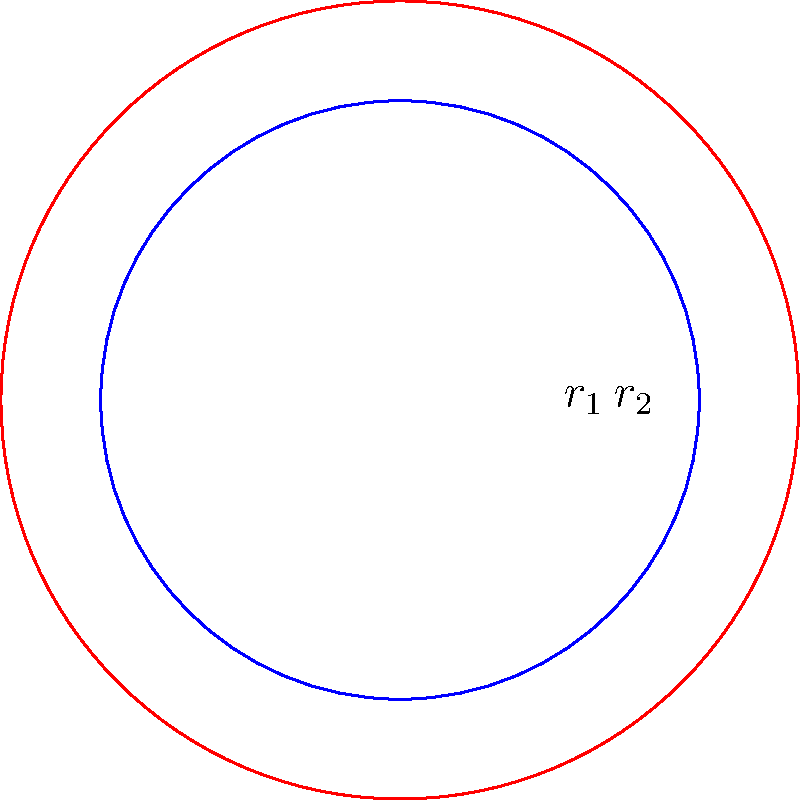As a music student, you're exploring the relationship between drumhead size and pitch. You have two circular drumheads with radii $r_1 = 3$ cm and $r_2 = 4$ cm. The frequency of a drumhead is inversely proportional to its radius, and the pitch is directly related to frequency. If the smaller drumhead produces a frequency of 440 Hz (A4), what is the frequency of the larger drumhead to the nearest Hz? Let's approach this step-by-step:

1) We know that frequency ($f$) is inversely proportional to radius ($r$). This means:

   $f \propto \frac{1}{r}$ or $f = k \cdot \frac{1}{r}$, where $k$ is a constant.

2) For the smaller drumhead:
   $f_1 = 440$ Hz, $r_1 = 3$ cm

3) For the larger drumhead:
   $f_2 = ?$, $r_2 = 4$ cm

4) Using the proportionality, we can set up an equation:

   $\frac{f_1}{f_2} = \frac{r_2}{r_1}$

5) Substituting the known values:

   $\frac{440}{f_2} = \frac{4}{3}$

6) Cross multiply:

   $440 \cdot 3 = f_2 \cdot 4$

7) Solve for $f_2$:

   $f_2 = \frac{440 \cdot 3}{4} = 330$ Hz

Therefore, the frequency of the larger drumhead is 330 Hz to the nearest Hz.
Answer: 330 Hz 